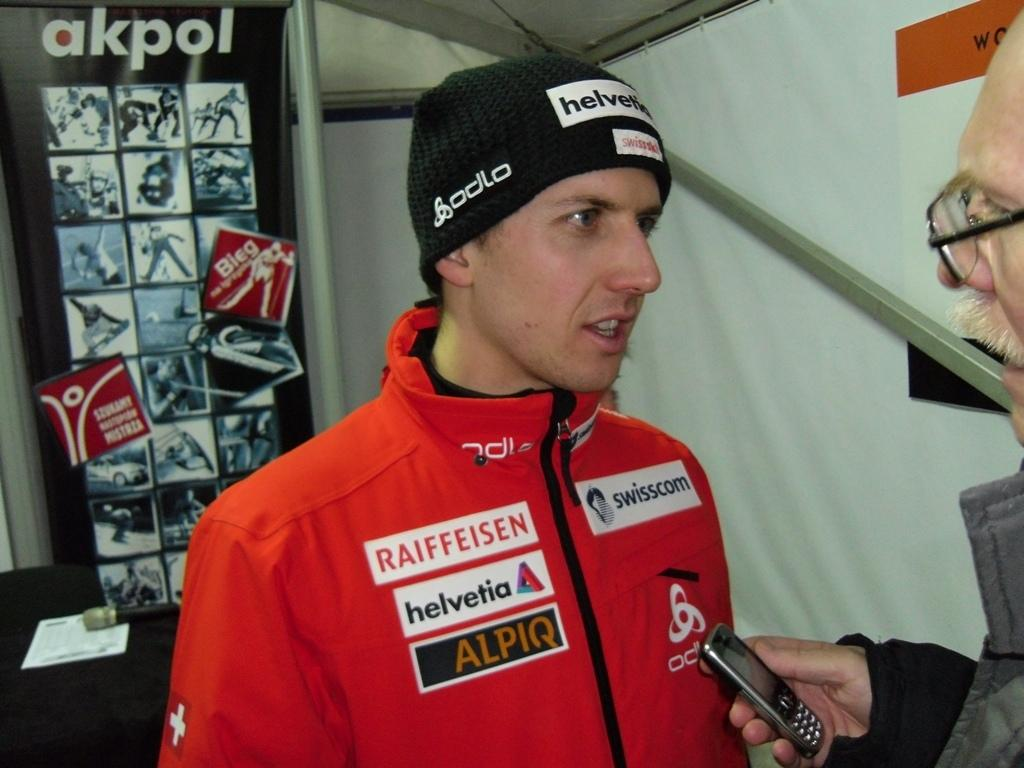<image>
Create a compact narrative representing the image presented. A man in cold weather wear with sponsors such as Swisscom and Hevetia on it. 